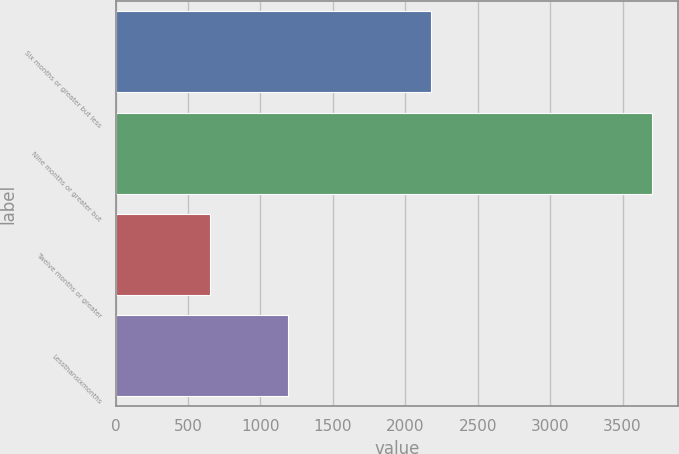Convert chart. <chart><loc_0><loc_0><loc_500><loc_500><bar_chart><fcel>Six months or greater but less<fcel>Nine months or greater but<fcel>Twelve months or greater<fcel>Lessthansixmonths<nl><fcel>2180<fcel>3700<fcel>650<fcel>1190<nl></chart> 